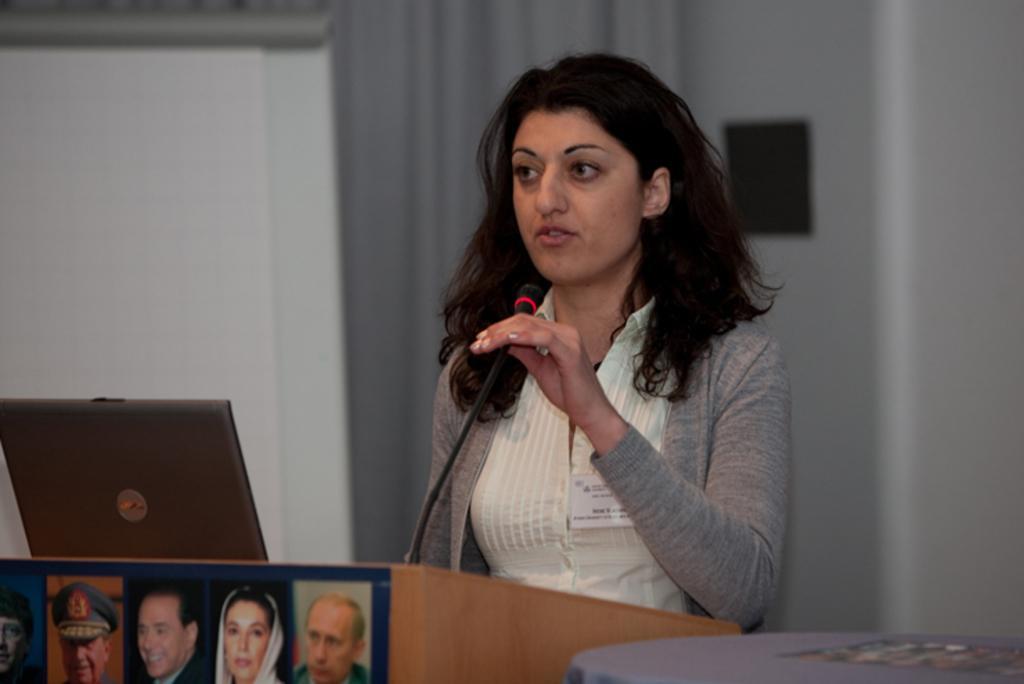Describe this image in one or two sentences. In this image we can see a woman standing in front of the podium, on the podium, we can see some photographs, mic and a laptop, in the background, we can see a projector, curtain and the wall, also we can see a table with poster on it. 